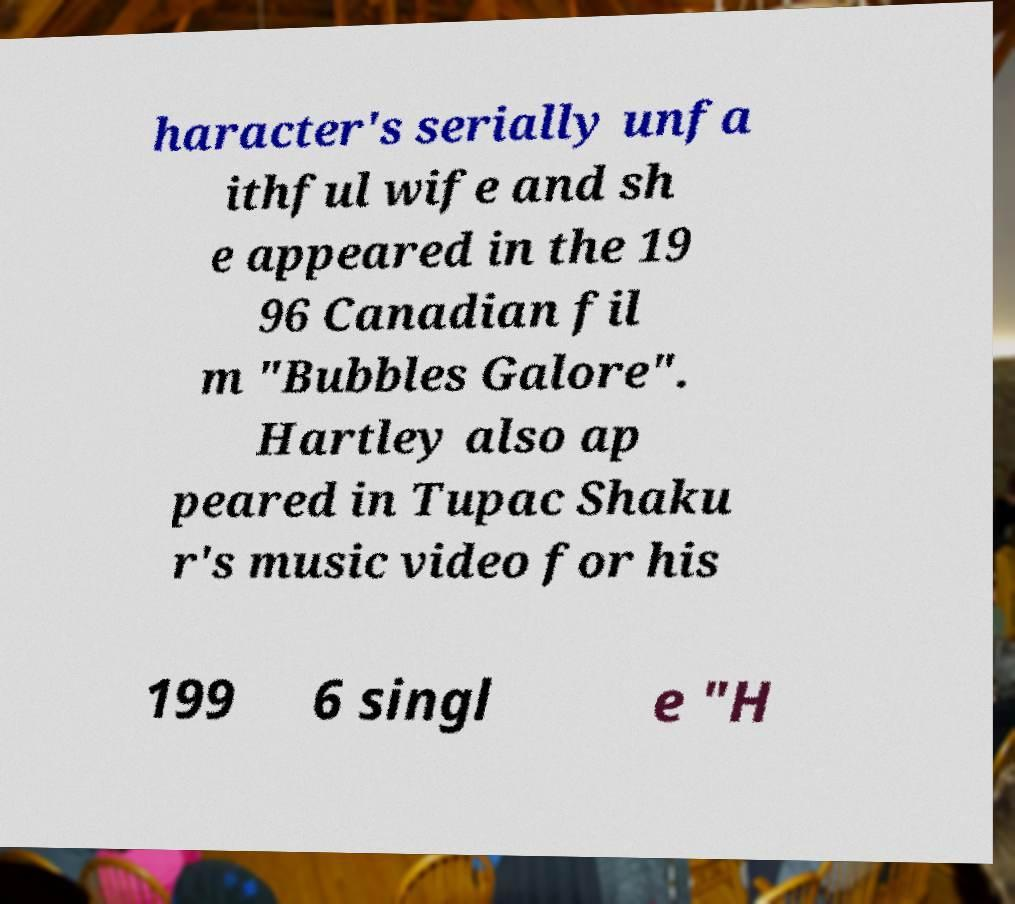For documentation purposes, I need the text within this image transcribed. Could you provide that? haracter's serially unfa ithful wife and sh e appeared in the 19 96 Canadian fil m "Bubbles Galore". Hartley also ap peared in Tupac Shaku r's music video for his 199 6 singl e "H 